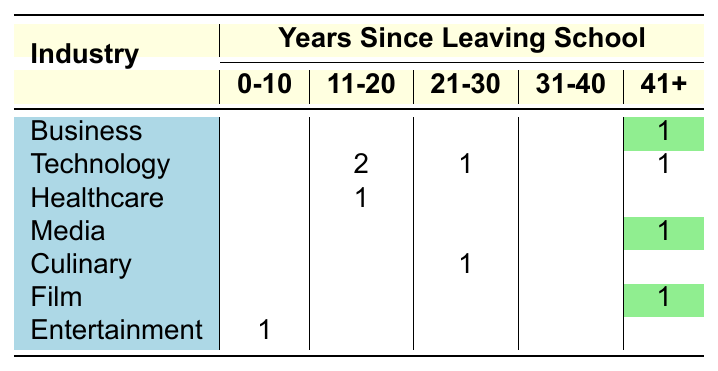What is the total number of successful dropouts in the Technology industry? There are four individuals listed in the Technology industry: Mark Zuckerberg, Evan Williams, David Karp, and Steve Jobs. The respective years since leaving school are 18, 23, 12, and 42. Thus, the total count is 4.
Answer: 4 Which industry has the highest number of dropouts who left school for more than 40 years? One individual from the Business industry (Richard Branson), one from Media (Oprah Winfrey), one from Film (James Cameron), and one from Technology (Steve Jobs) left school over 40 years ago. Therefore, there are four individuals across three industries. The Business, Media, and Film industries all have one individual each leaving over 40 years.
Answer: 4 Is there a dropout in the Culinary industry who left school between 21-30 years ago? In the Culinary industry, there is one individual, Rachael Ray, who left school 24 years ago, which falls in the 21-30 years range. Therefore, yes, there is a dropout matching the criteria.
Answer: Yes What is the total count of dropouts who left school between 11-20 years ago? From the table, counting the individuals who left school in this range includes Elizabeth Holmes (15 years) and Evan Williams (20 years), for a total of 2.
Answer: 2 How many more dropouts are there in the Entertainment industry compared to the Healthcare industry? The Entertainment industry has one dropout (Miley Cyrus), while the Healthcare industry has one dropout (Elizabeth Holmes). Therefore, subtracting the two gives us 1 - 1 = 0.
Answer: 0 